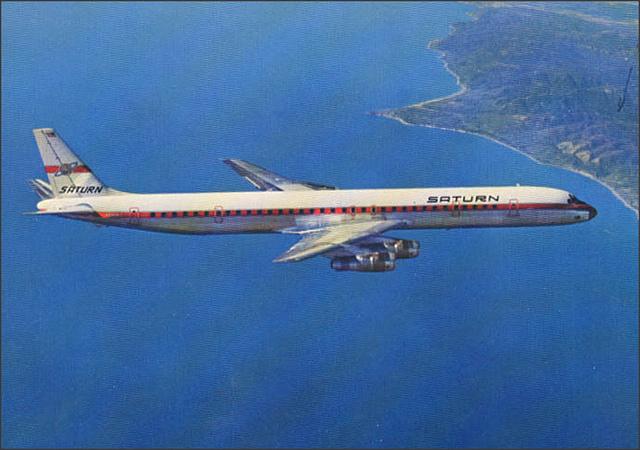What perspective is the photo taken from?
Write a very short answer. Above. What is the name of the plane?
Concise answer only. Saturn. Which corner is the land in this picture?
Keep it brief. Upper right. Are we looking up or down at the plane?
Keep it brief. Down. What is below the plane?
Concise answer only. Water. 